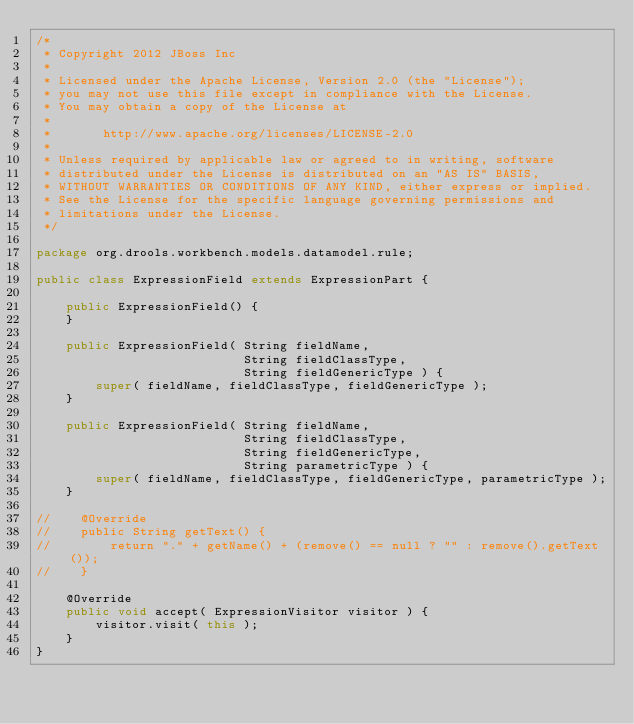Convert code to text. <code><loc_0><loc_0><loc_500><loc_500><_Java_>/*
 * Copyright 2012 JBoss Inc
 *
 * Licensed under the Apache License, Version 2.0 (the "License");
 * you may not use this file except in compliance with the License.
 * You may obtain a copy of the License at
 *
 *       http://www.apache.org/licenses/LICENSE-2.0
 *
 * Unless required by applicable law or agreed to in writing, software
 * distributed under the License is distributed on an "AS IS" BASIS,
 * WITHOUT WARRANTIES OR CONDITIONS OF ANY KIND, either express or implied.
 * See the License for the specific language governing permissions and
 * limitations under the License.
 */

package org.drools.workbench.models.datamodel.rule;

public class ExpressionField extends ExpressionPart {

    public ExpressionField() {
    }

    public ExpressionField( String fieldName,
                            String fieldClassType,
                            String fieldGenericType ) {
        super( fieldName, fieldClassType, fieldGenericType );
    }

    public ExpressionField( String fieldName,
                            String fieldClassType,
                            String fieldGenericType,
                            String parametricType ) {
        super( fieldName, fieldClassType, fieldGenericType, parametricType );
    }

//    @Override
//    public String getText() {
//        return "." + getName() + (remove() == null ? "" : remove().getText());
//    }

    @Override
    public void accept( ExpressionVisitor visitor ) {
        visitor.visit( this );
    }
}
</code> 